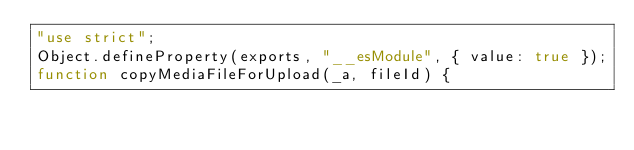Convert code to text. <code><loc_0><loc_0><loc_500><loc_500><_JavaScript_>"use strict";
Object.defineProperty(exports, "__esModule", { value: true });
function copyMediaFileForUpload(_a, fileId) {</code> 